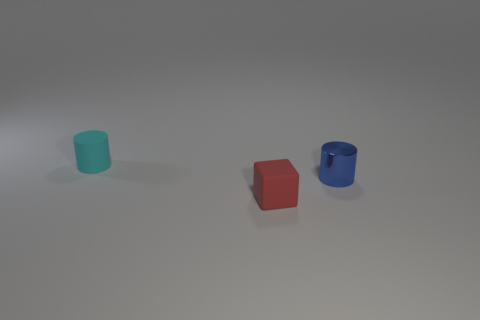Subtract all blue cylinders. How many cylinders are left? 1 Subtract 1 cylinders. How many cylinders are left? 1 Add 1 small blue things. How many objects exist? 4 Subtract 0 green balls. How many objects are left? 3 Subtract all blocks. How many objects are left? 2 Subtract all purple cylinders. Subtract all blue balls. How many cylinders are left? 2 Subtract all cyan balls. How many blue cylinders are left? 1 Subtract all tiny cyan metal cylinders. Subtract all blue metal cylinders. How many objects are left? 2 Add 1 blue cylinders. How many blue cylinders are left? 2 Add 2 cyan shiny cubes. How many cyan shiny cubes exist? 2 